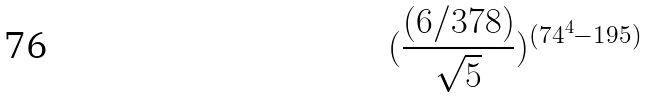Convert formula to latex. <formula><loc_0><loc_0><loc_500><loc_500>( \frac { ( 6 / 3 7 8 ) } { \sqrt { 5 } } ) ^ { ( 7 4 ^ { 4 } - 1 9 5 ) }</formula> 